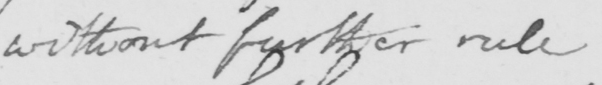Please transcribe the handwritten text in this image. without further rule 